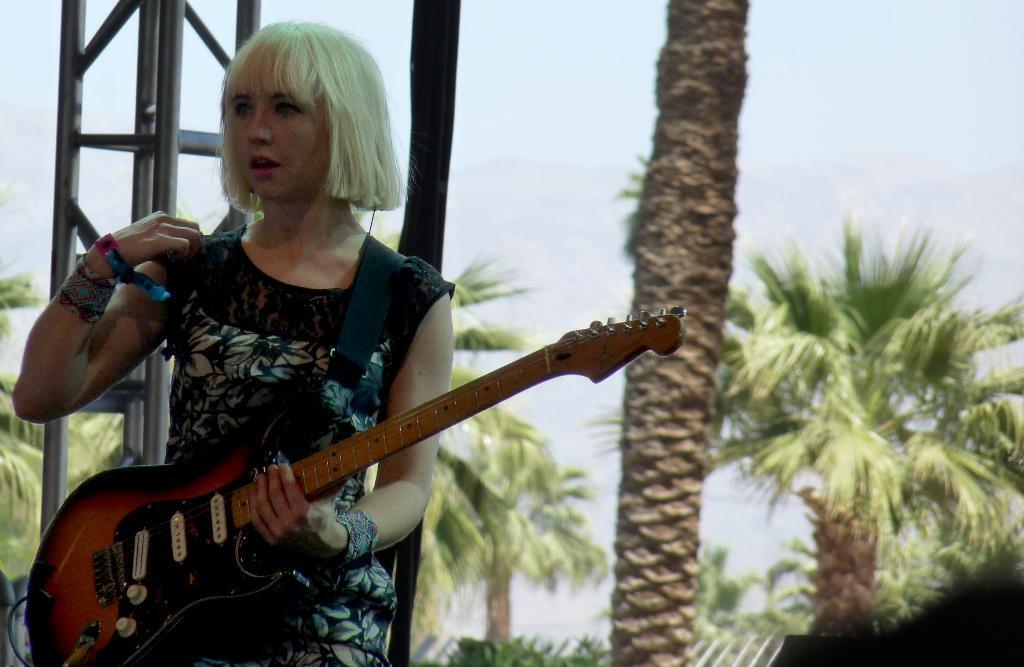Please provide a concise description of this image. In this Image I see a woman who is holding a guitar in her hands and In the background I see trees. 